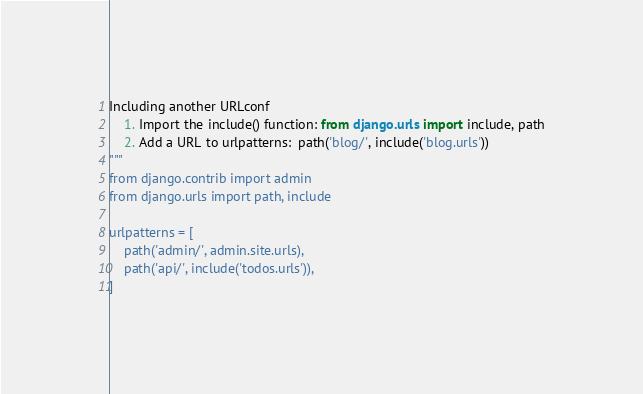Convert code to text. <code><loc_0><loc_0><loc_500><loc_500><_Python_>Including another URLconf
    1. Import the include() function: from django.urls import include, path
    2. Add a URL to urlpatterns:  path('blog/', include('blog.urls'))
"""
from django.contrib import admin
from django.urls import path, include

urlpatterns = [
    path('admin/', admin.site.urls),
    path('api/', include('todos.urls')),
]
</code> 